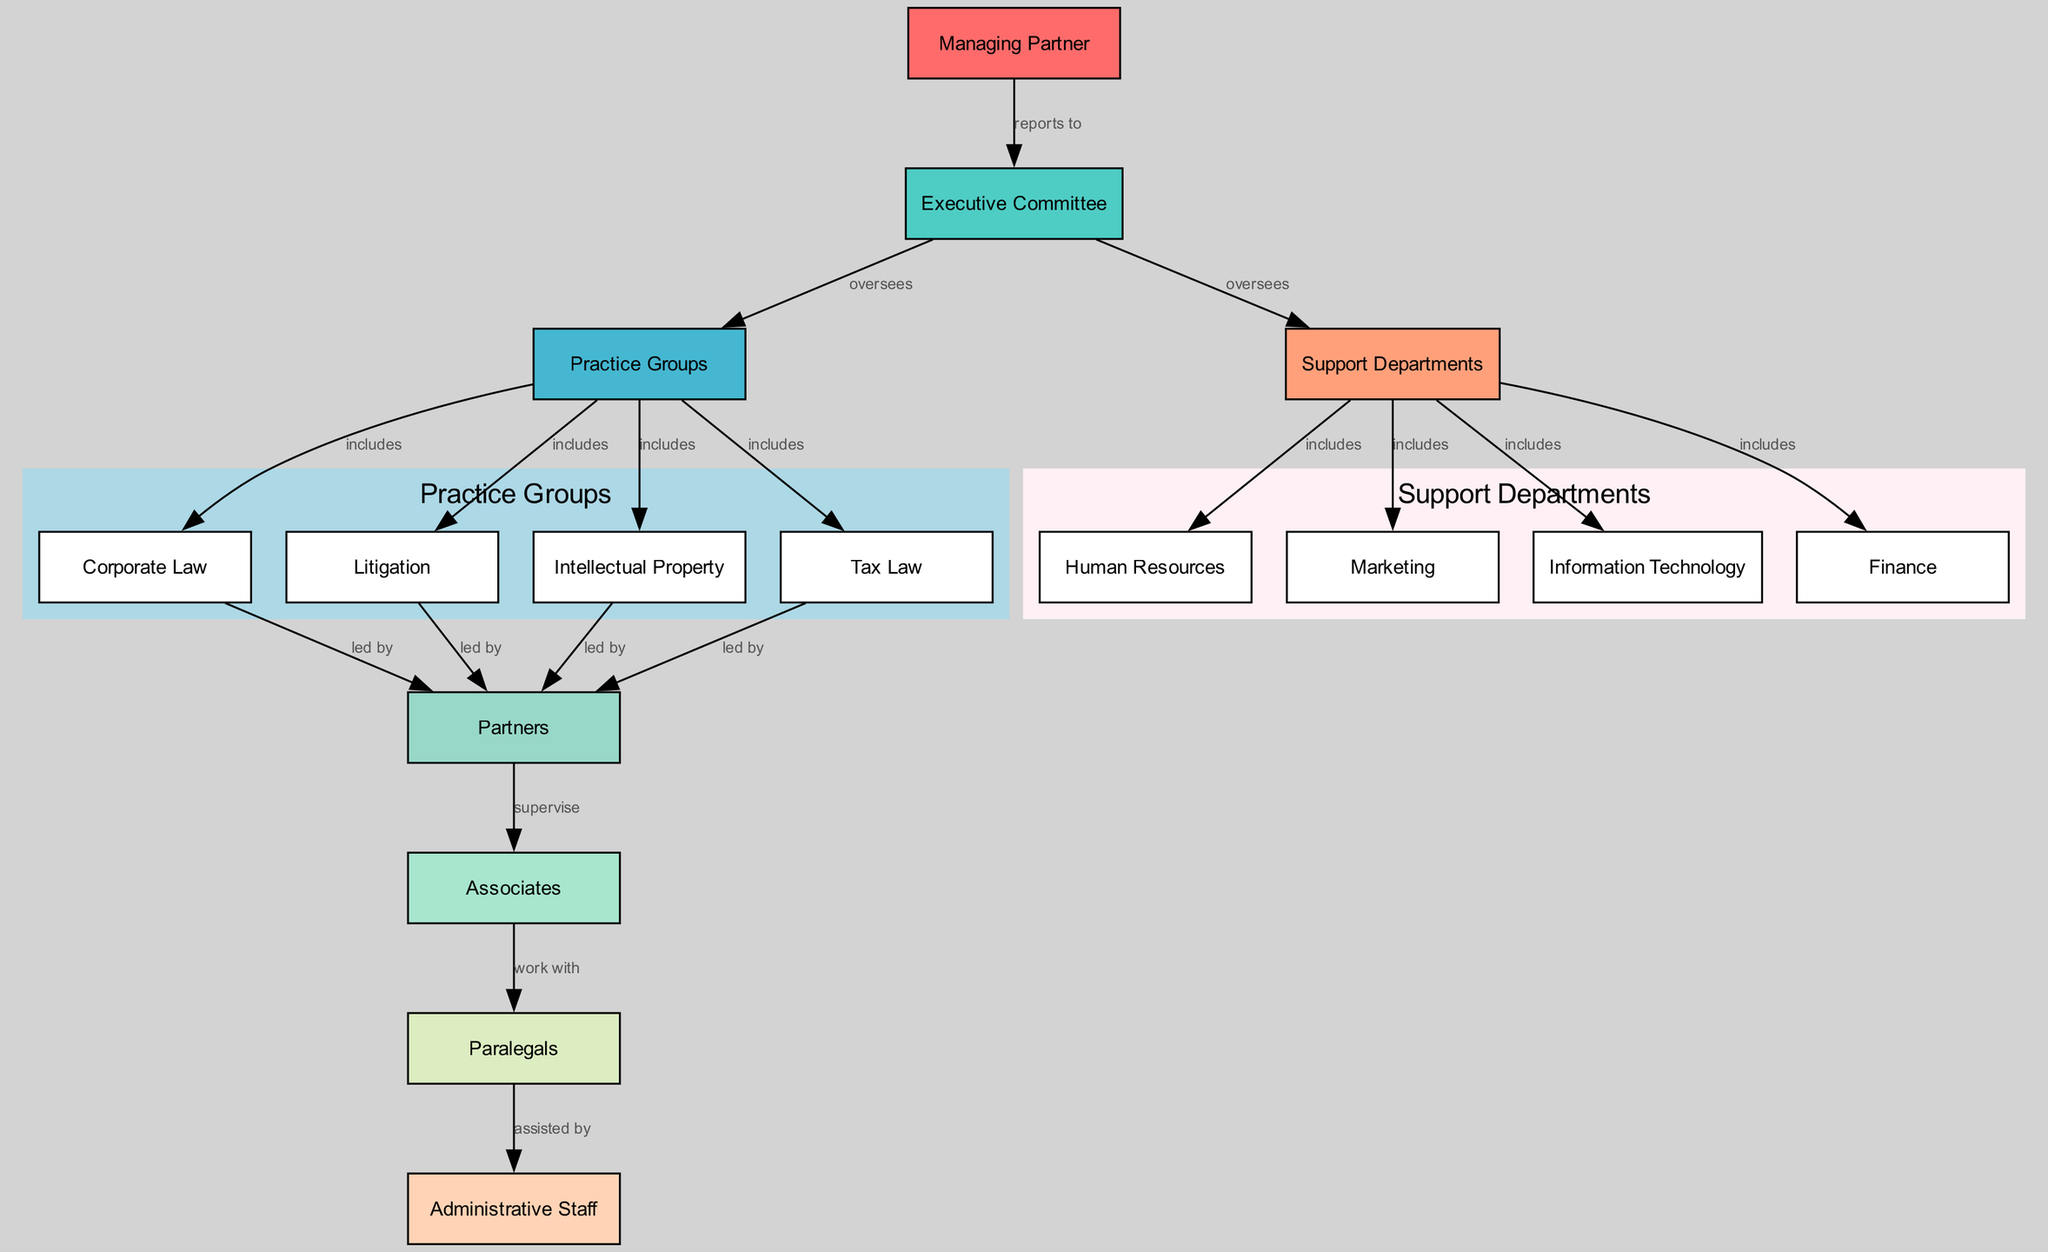What is the highest position in the law firm's hierarchy? The highest position is labeled as "Managing Partner," which is indicated prominently at the top of the organizational structure.
Answer: Managing Partner How many practice groups are included in the diagram? There are four practice groups indicated by the nodes labeled "Corporate Law," "Litigation," "Intellectual Property," and "Tax Law."
Answer: Four Which department oversees the Support Departments? The "Executive Committee" is shown to oversee the "Support Departments," which is indicated by the edge connecting these two nodes.
Answer: Executive Committee What role do "Partners" have in relation to "Associates"? The "Partners" supervise "Associates," as specified by the label on the edge connecting these two roles.
Answer: Supervise Which support department includes "Marketing"? "Marketing" is included under the "Support Departments," which is shown as one of the edges connecting them.
Answer: Support Departments Who reports to the "Managing Partner"? The "Executive Committee" is the entity that reports to the "Managing Partner," as indicated by the directed edge in the diagram.
Answer: Executive Committee How many edges are in the diagram? By counting the arrows (edges) connecting the nodes, there are a total of 14 edges in the organizational structure.
Answer: Fourteen What type of staff works with "Associates"? "Paralegals" are indicated to work with "Associates," connected by the edge labeled "work with."
Answer: Paralegals Which groups fall under the "Practice Groups"? The "Practice Groups" include "Corporate Law," "Litigation," "Intellectual Property," and "Tax Law," as shown by the connections that are classified under this category.
Answer: Corporate Law, Litigation, Intellectual Property, Tax Law 